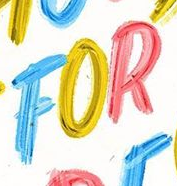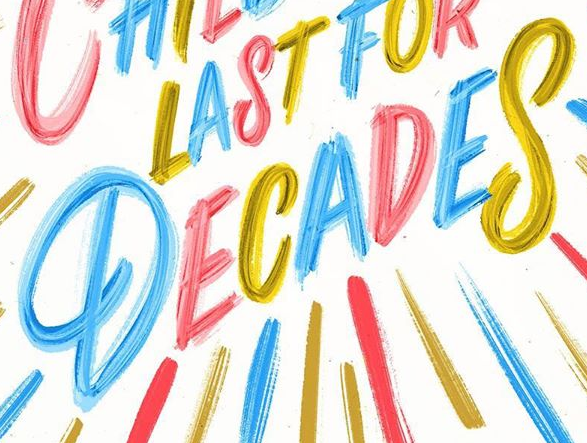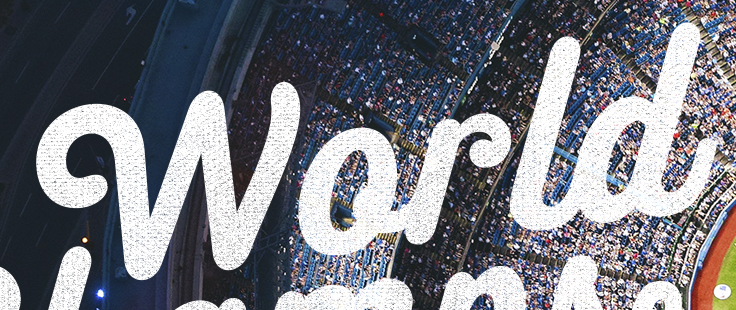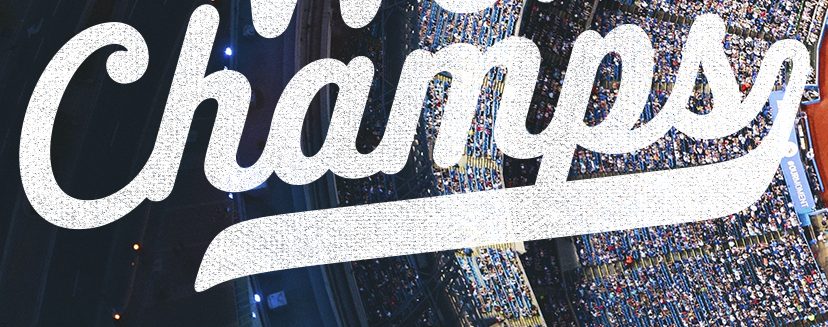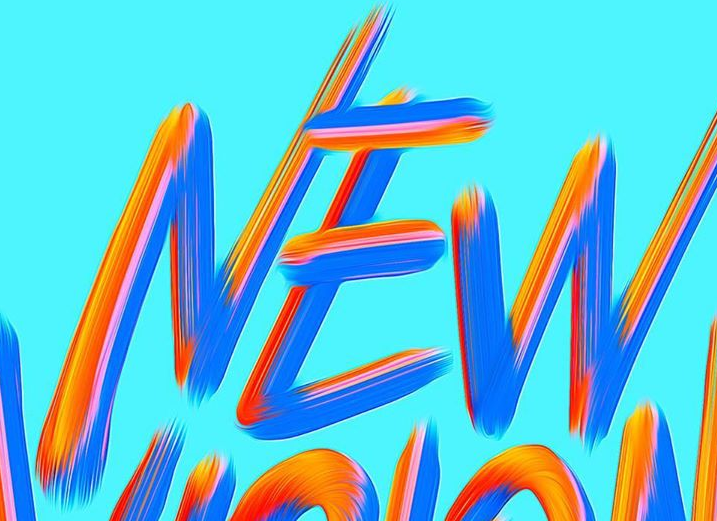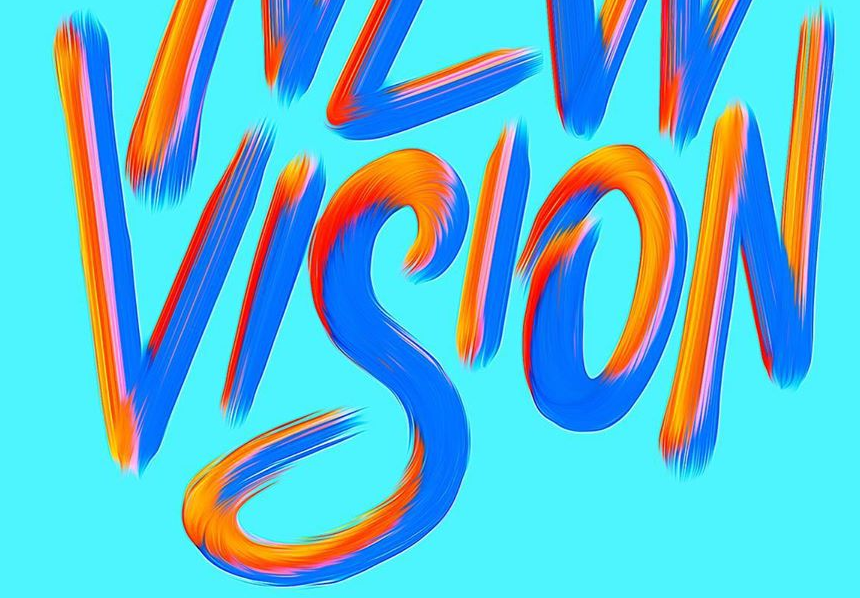Identify the words shown in these images in order, separated by a semicolon. FOR; DECADES; World; Champs; NEW; VISION 